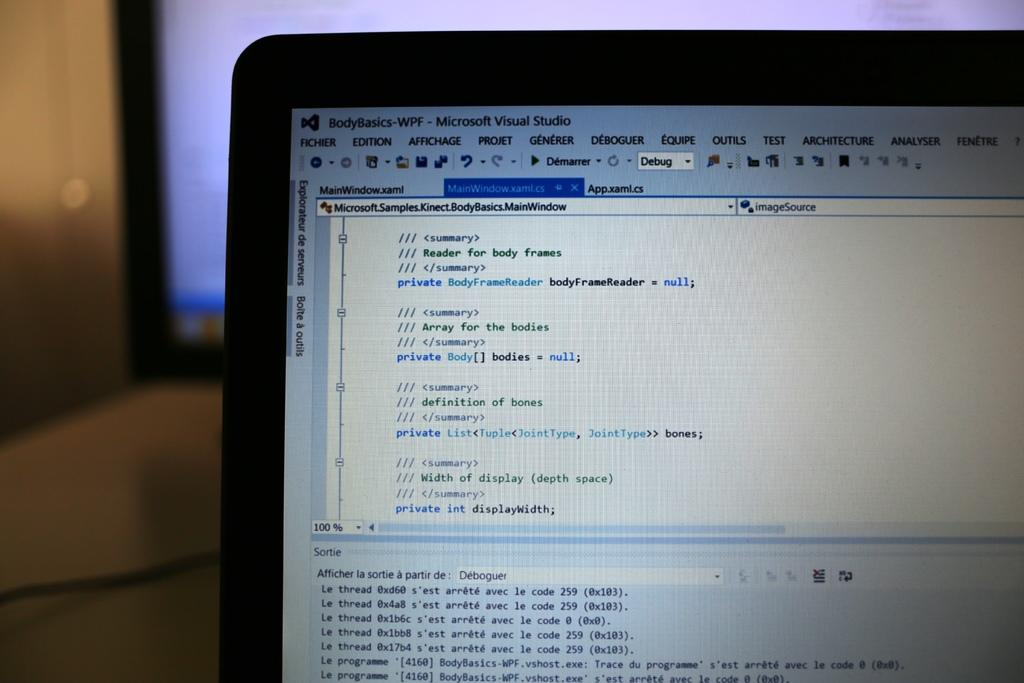<image>
Share a concise interpretation of the image provided. a partial laptop screen filled with Microsoft Visual Studio code 